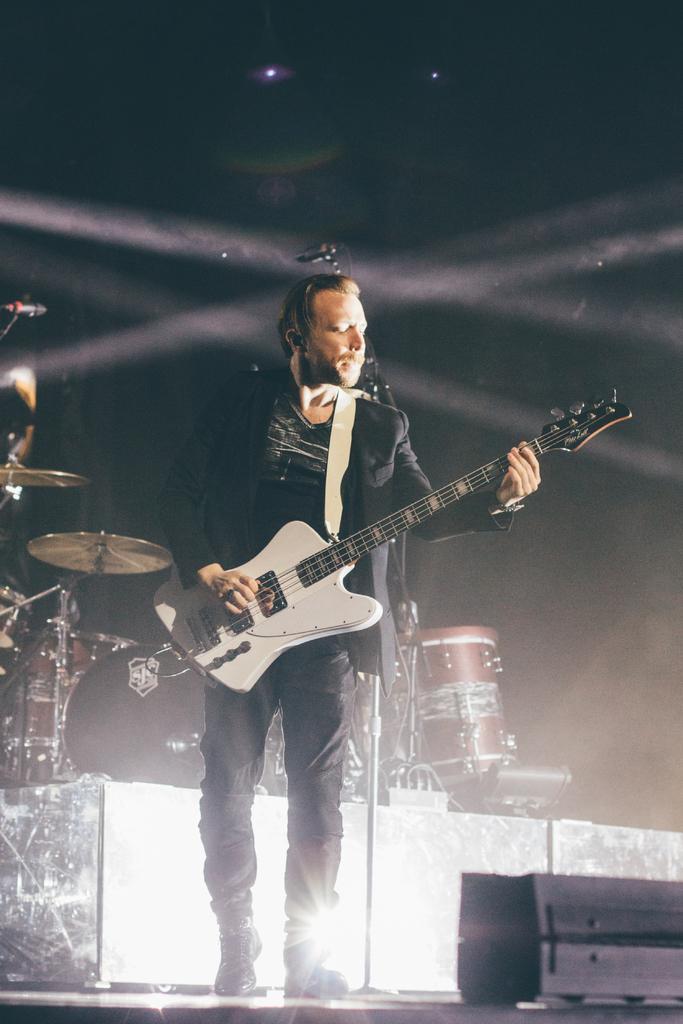In one or two sentences, can you explain what this image depicts? In this image there is a person wearing black color dress playing guitar and at the background of the image there are drums and microphones. 